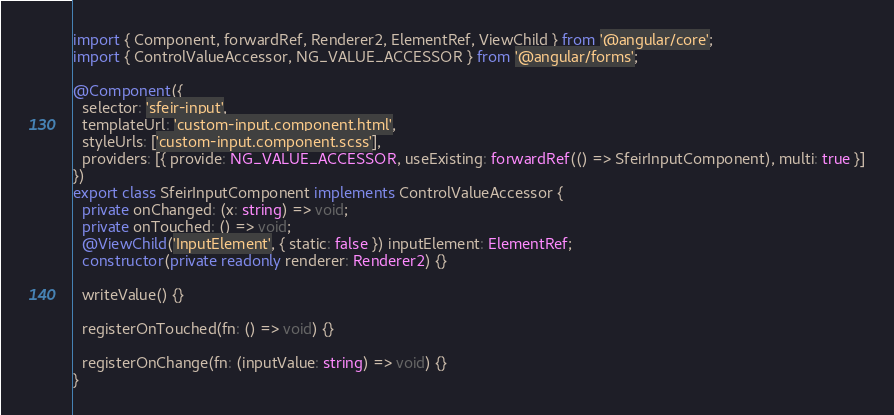Convert code to text. <code><loc_0><loc_0><loc_500><loc_500><_TypeScript_>import { Component, forwardRef, Renderer2, ElementRef, ViewChild } from '@angular/core';
import { ControlValueAccessor, NG_VALUE_ACCESSOR } from '@angular/forms';

@Component({
  selector: 'sfeir-input',
  templateUrl: 'custom-input.component.html',
  styleUrls: ['custom-input.component.scss'],
  providers: [{ provide: NG_VALUE_ACCESSOR, useExisting: forwardRef(() => SfeirInputComponent), multi: true }]
})
export class SfeirInputComponent implements ControlValueAccessor {
  private onChanged: (x: string) => void;
  private onTouched: () => void;
  @ViewChild('InputElement', { static: false }) inputElement: ElementRef;
  constructor(private readonly renderer: Renderer2) {}

  writeValue() {}

  registerOnTouched(fn: () => void) {}

  registerOnChange(fn: (inputValue: string) => void) {}
}
</code> 